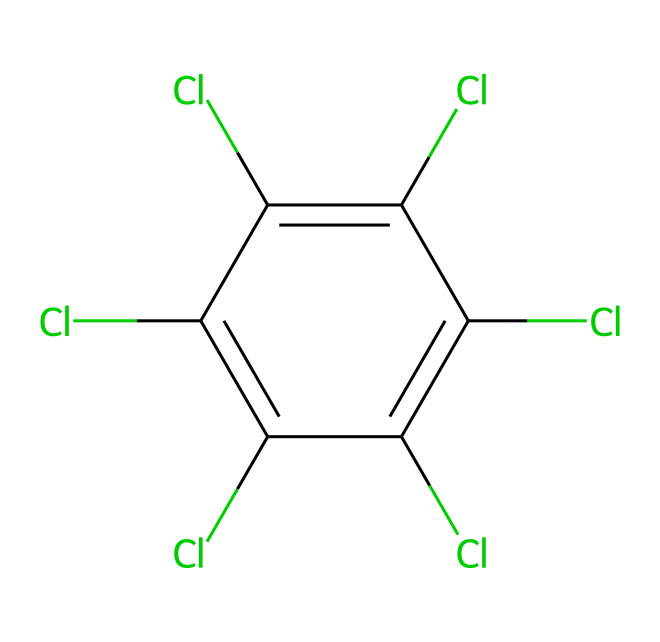What is the molecular formula of chlorothalonil? To determine the molecular formula, we analyze the SMILES representation. Each letter represents an atom: C (Carbon), Cl (Chlorine), and we count them. In this structure, there are 8 Carbon atoms and 6 Chlorine atoms, totaling the molecular formula as C8Cl6.
Answer: C8Cl6 How many chlorine atoms are present in chlorothalonil? By examining the SMILES structure, we can see the "Cl" appears six times, indicating there are a total of six chlorine atoms in the chemical.
Answer: 6 What type of compound is chlorothalonil classified as? Chlorothalonil is identified as a fungicide. This classification is based on its use and structure, which is designed to inhibit fungal growth.
Answer: fungicide What type of bonding is mainly present in chlorothalonil? The primary type of bonding in chlorothalonil is covalent bonding, as the structure is composed of many carbon-chlorine bonds formed by sharing electrons.
Answer: covalent What is the overall charge of chlorothalonil? In examining the structure, chlorothalonil has no charges indicated in the SMILES notation. The atom count and types do not exhibit any ionic charges, suggesting it is neutral.
Answer: neutral How many rings are present in the structure of chlorothalonil? Analyzing the structure reveals a single cyclic component in the arrangement of the carbon atoms. Therefore, there's one ring present in chlorothalonil.
Answer: 1 To which functional group does chlorothalonil belong? The structure indicates multiple substituents on a carbon framework, specifically including chlorinated aromatic compounds which suggest it belongs to the halogenated aromatic compounds class.
Answer: halogenated aromatic 